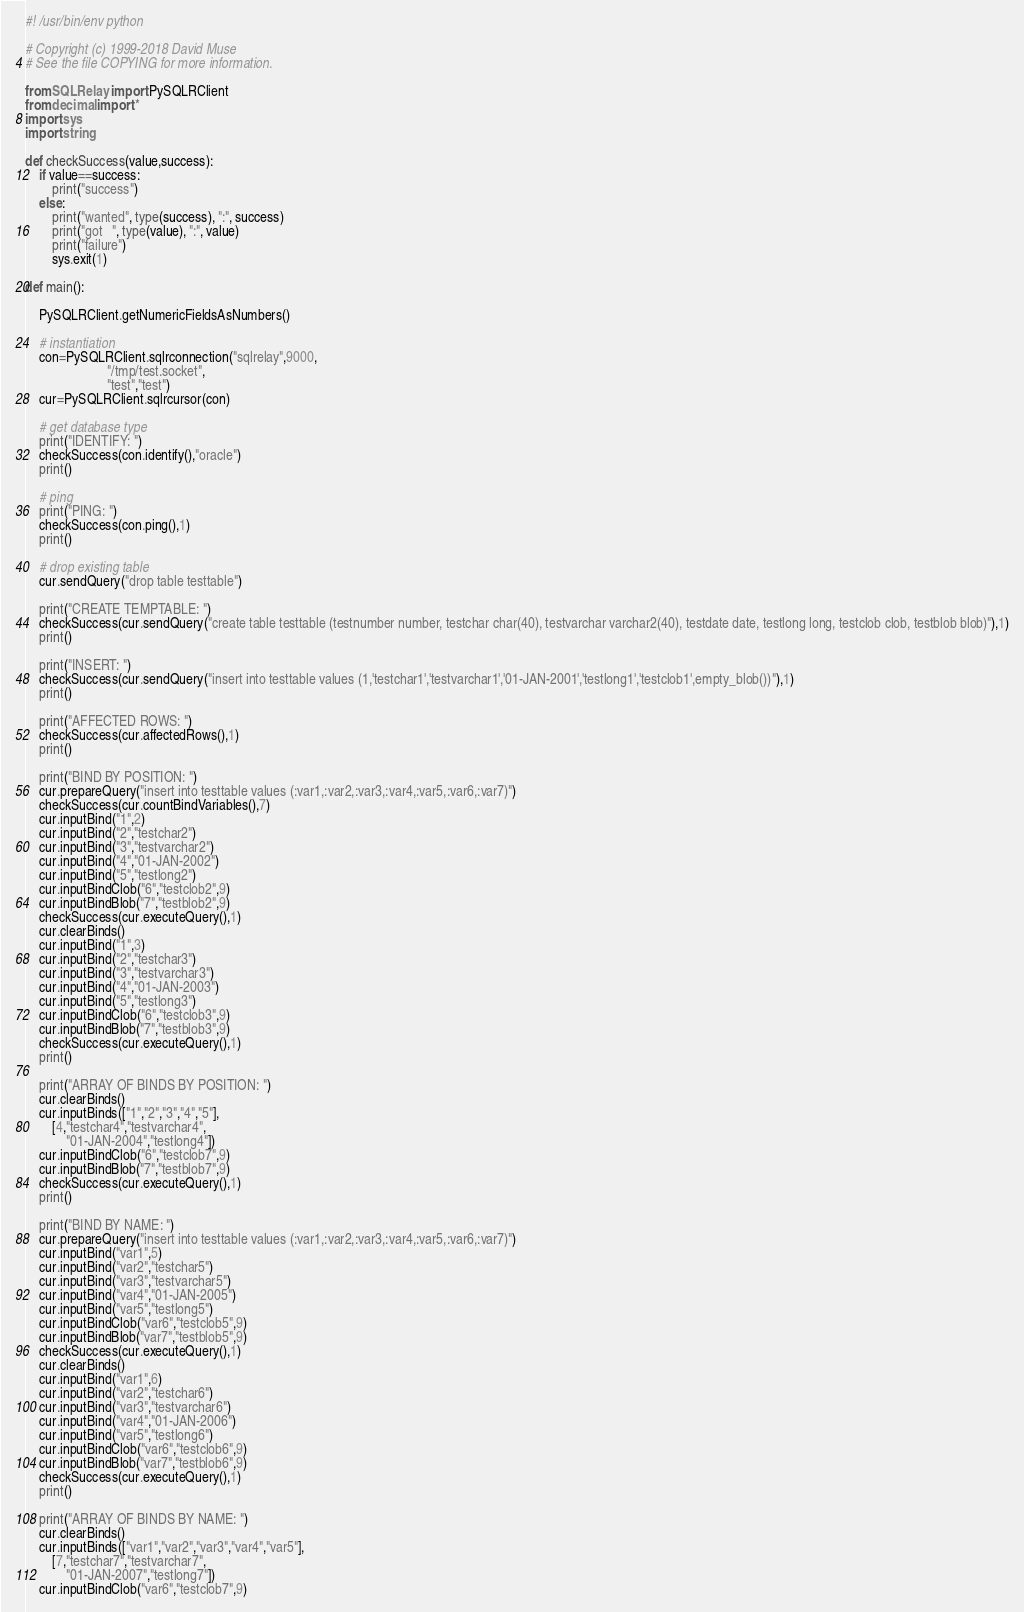<code> <loc_0><loc_0><loc_500><loc_500><_Python_>#! /usr/bin/env python

# Copyright (c) 1999-2018 David Muse
# See the file COPYING for more information.

from SQLRelay import PySQLRClient
from decimal import *
import sys
import string

def checkSuccess(value,success):
	if value==success:
		print("success")
	else:
		print("wanted", type(success), ":", success)
		print("got   ", type(value), ":", value)
		print("failure")
		sys.exit(1)

def main():

	PySQLRClient.getNumericFieldsAsNumbers()

	# instantiation
	con=PySQLRClient.sqlrconnection("sqlrelay",9000,
						"/tmp/test.socket",
						"test","test")
	cur=PySQLRClient.sqlrcursor(con)

	# get database type
	print("IDENTIFY: ")
	checkSuccess(con.identify(),"oracle")
	print()

	# ping
	print("PING: ")
	checkSuccess(con.ping(),1)
	print()

	# drop existing table
	cur.sendQuery("drop table testtable")

	print("CREATE TEMPTABLE: ")
	checkSuccess(cur.sendQuery("create table testtable (testnumber number, testchar char(40), testvarchar varchar2(40), testdate date, testlong long, testclob clob, testblob blob)"),1)
	print()

	print("INSERT: ")
	checkSuccess(cur.sendQuery("insert into testtable values (1,'testchar1','testvarchar1','01-JAN-2001','testlong1','testclob1',empty_blob())"),1)
	print()

	print("AFFECTED ROWS: ")
	checkSuccess(cur.affectedRows(),1)
	print()

	print("BIND BY POSITION: ")
	cur.prepareQuery("insert into testtable values (:var1,:var2,:var3,:var4,:var5,:var6,:var7)")
	checkSuccess(cur.countBindVariables(),7)
	cur.inputBind("1",2)
	cur.inputBind("2","testchar2")
	cur.inputBind("3","testvarchar2")
	cur.inputBind("4","01-JAN-2002")
	cur.inputBind("5","testlong2")
	cur.inputBindClob("6","testclob2",9)
	cur.inputBindBlob("7","testblob2",9)
	checkSuccess(cur.executeQuery(),1)
	cur.clearBinds()
	cur.inputBind("1",3)
	cur.inputBind("2","testchar3")
	cur.inputBind("3","testvarchar3")
	cur.inputBind("4","01-JAN-2003")
	cur.inputBind("5","testlong3")
	cur.inputBindClob("6","testclob3",9)
	cur.inputBindBlob("7","testblob3",9)
	checkSuccess(cur.executeQuery(),1)
	print()

	print("ARRAY OF BINDS BY POSITION: ")
	cur.clearBinds()
	cur.inputBinds(["1","2","3","4","5"],
		[4,"testchar4","testvarchar4",
			"01-JAN-2004","testlong4"])
	cur.inputBindClob("6","testclob7",9)
	cur.inputBindBlob("7","testblob7",9)
	checkSuccess(cur.executeQuery(),1)
	print()

	print("BIND BY NAME: ")
	cur.prepareQuery("insert into testtable values (:var1,:var2,:var3,:var4,:var5,:var6,:var7)")
	cur.inputBind("var1",5)
	cur.inputBind("var2","testchar5")
	cur.inputBind("var3","testvarchar5")
	cur.inputBind("var4","01-JAN-2005")
	cur.inputBind("var5","testlong5")
	cur.inputBindClob("var6","testclob5",9)
	cur.inputBindBlob("var7","testblob5",9)
	checkSuccess(cur.executeQuery(),1)
	cur.clearBinds()
	cur.inputBind("var1",6)
	cur.inputBind("var2","testchar6")
	cur.inputBind("var3","testvarchar6")
	cur.inputBind("var4","01-JAN-2006")
	cur.inputBind("var5","testlong6")
	cur.inputBindClob("var6","testclob6",9)
	cur.inputBindBlob("var7","testblob6",9)
	checkSuccess(cur.executeQuery(),1)
	print()

	print("ARRAY OF BINDS BY NAME: ")
	cur.clearBinds()
	cur.inputBinds(["var1","var2","var3","var4","var5"],
		[7,"testchar7","testvarchar7",
			"01-JAN-2007","testlong7"])
	cur.inputBindClob("var6","testclob7",9)</code> 